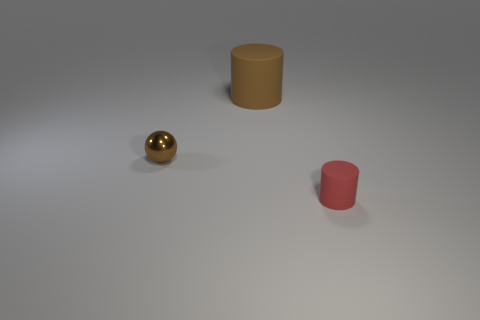Is there any other thing that is the same shape as the small brown metallic thing?
Keep it short and to the point. No. Is the color of the matte cylinder in front of the brown metallic object the same as the big cylinder?
Ensure brevity in your answer.  No. How many gray things are the same shape as the tiny red matte object?
Ensure brevity in your answer.  0. Are there an equal number of matte cylinders in front of the tiny cylinder and big rubber things?
Keep it short and to the point. No. There is a shiny ball that is the same size as the red object; what color is it?
Ensure brevity in your answer.  Brown. Are there any other big objects that have the same shape as the red matte thing?
Keep it short and to the point. Yes. There is a tiny object that is to the left of the cylinder left of the matte object in front of the big brown object; what is its material?
Your answer should be very brief. Metal. What number of other things are there of the same size as the brown ball?
Ensure brevity in your answer.  1. The large matte cylinder is what color?
Keep it short and to the point. Brown. How many rubber things are large things or tiny things?
Your answer should be very brief. 2. 